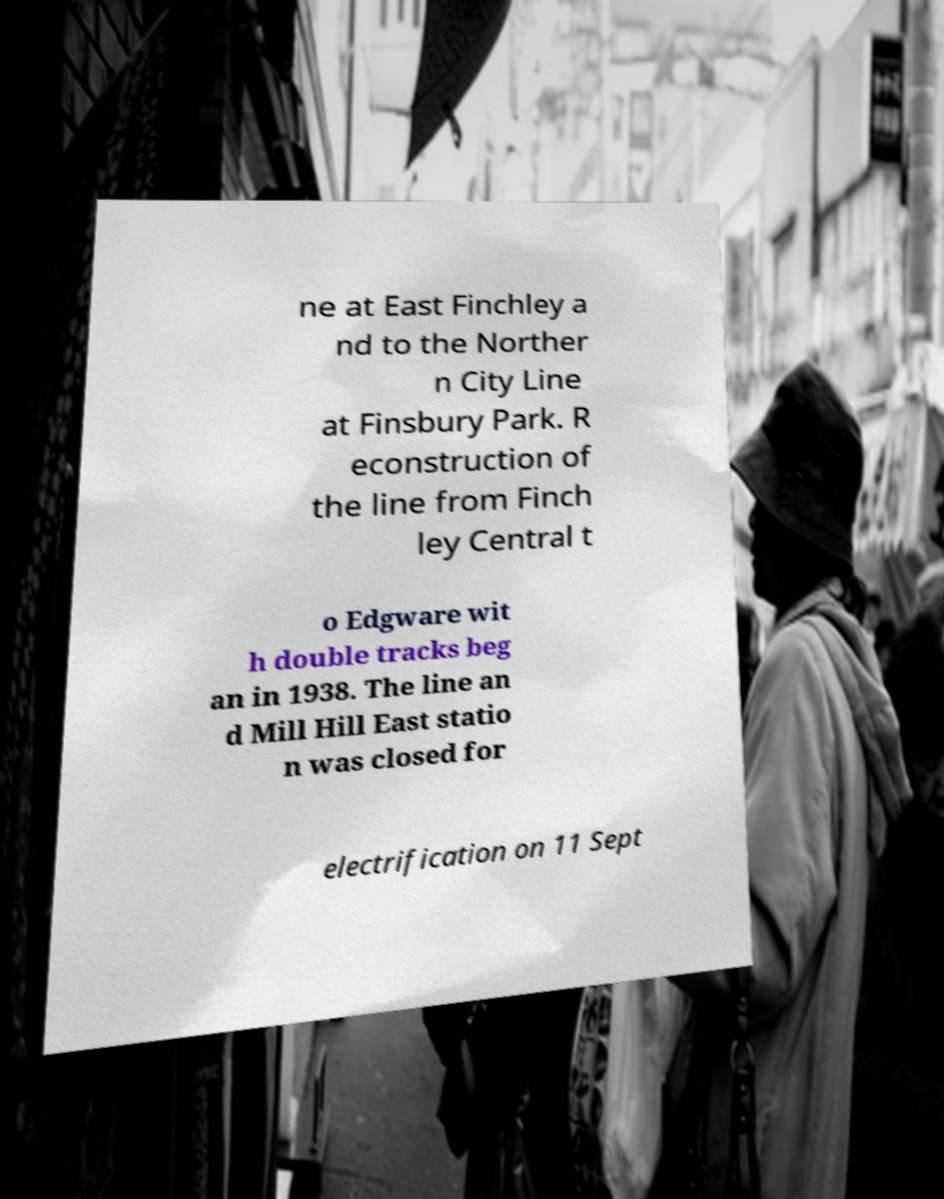Can you accurately transcribe the text from the provided image for me? ne at East Finchley a nd to the Norther n City Line at Finsbury Park. R econstruction of the line from Finch ley Central t o Edgware wit h double tracks beg an in 1938. The line an d Mill Hill East statio n was closed for electrification on 11 Sept 